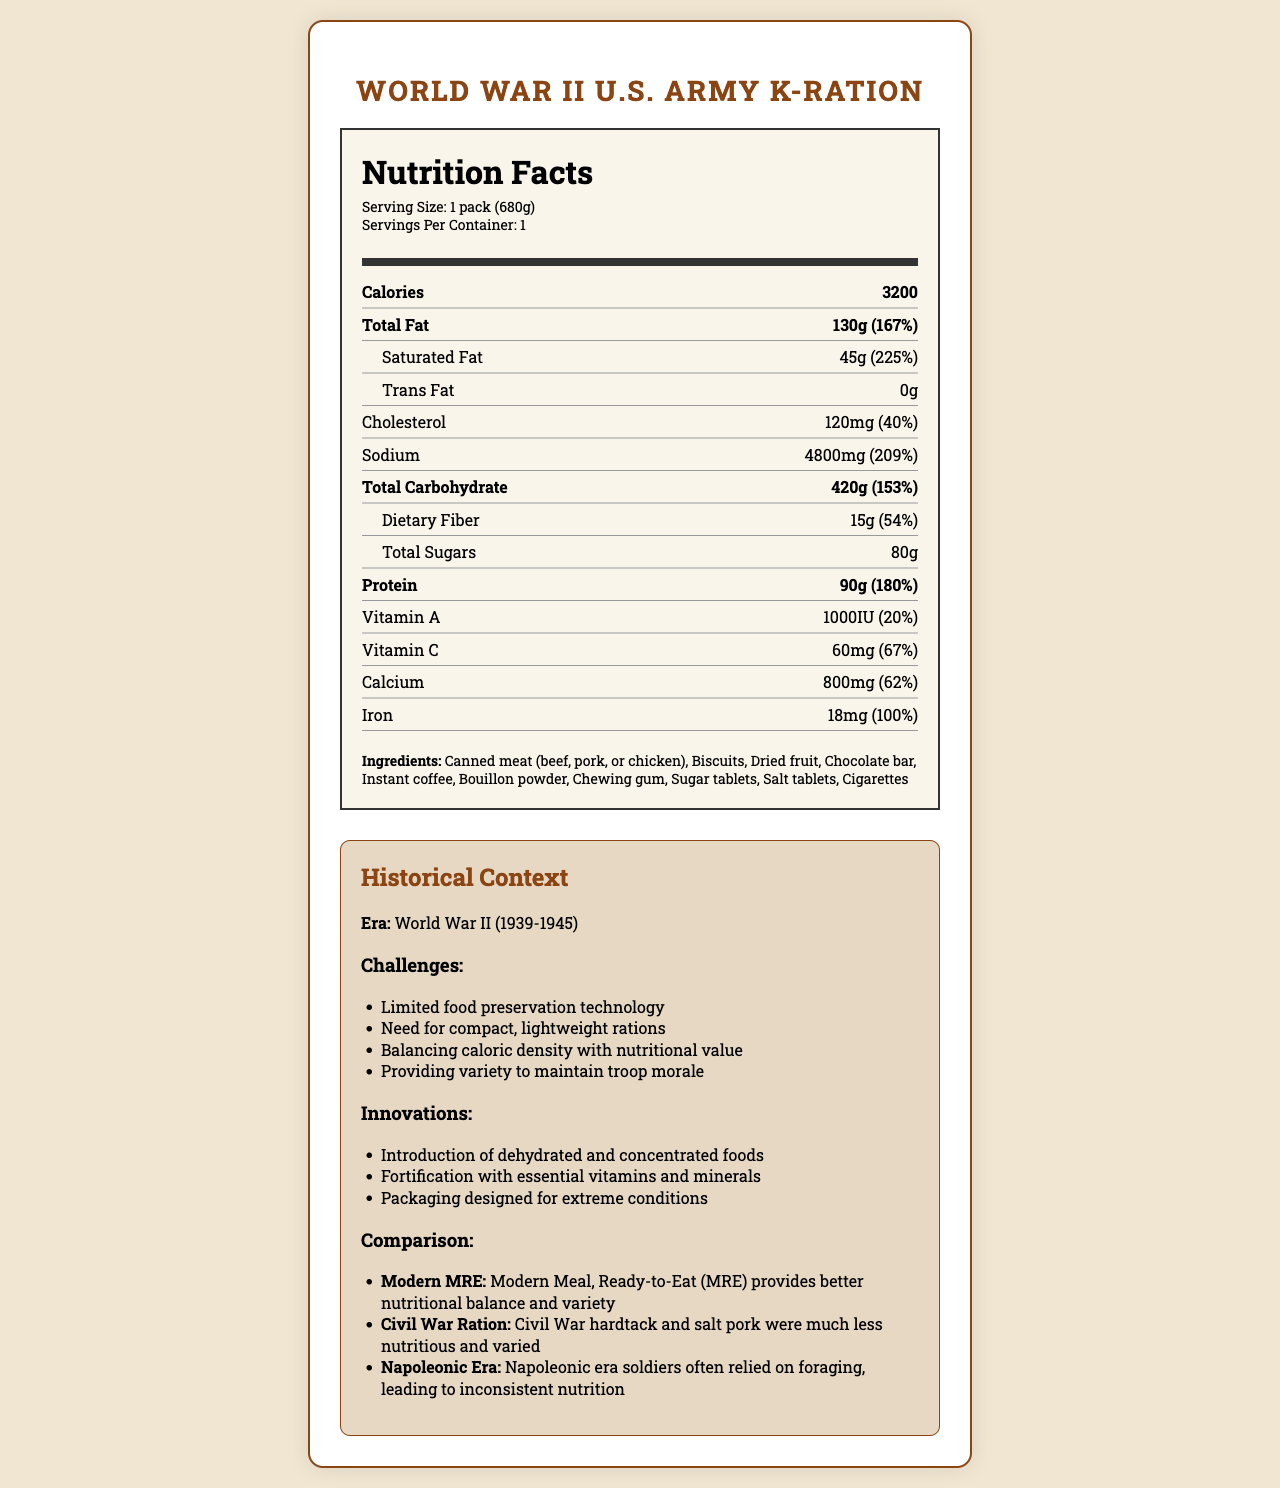what is the serving size for the World War II U.S. Army K-Ration? The serving size is explicitly mentioned at the beginning of the Nutrition Facts section as "Serving Size: 1 pack (680g)".
Answer: 1 pack (680g) how many calories does one K-Ration pack provide? The document states "Calories: 3200" under the Nutrition Facts section.
Answer: 3200 how much protein is there per serving of the K-Ration? The amount of protein per serving is listed as "Protein: 90g (180%)".
Answer: 90g what percentage of the daily value of sodium does a K-Ration contain? The daily value percentage for sodium is given as "Sodium: 4800mg (209%)".
Answer: 209% what were some challenges faced during the World War II era regarding rations? The section under Historical Context lists these challenges explicitly.
Answer: Limited food preservation technology, Need for compact, lightweight rations, Balancing caloric density with nutritional value, Providing variety to maintain troop morale how much total fat is in a K-Ration pack? A. 90g B. 130g C. 150g D. 45g The nutrition facts state "Total Fat: 130g (167%)".
Answer: B. 130g which of the following was not an ingredient in the K-Ration? I. Instant coffee II. Chocolate bar III. Fresh vegetables IV. Chewing gum Fresh vegetables are not listed among the ingredients which include "Canned meat, Biscuits, Dried fruit, Chocolate bar, Instant coffee, Bouillon powder, Chewing gum, Sugar tablets, Salt tablets, Cigarettes".
Answer: III. Fresh vegetables Did K-Ration packs include Vitamin C? The Nutrition Facts include "Vitamin C: 60mg (67%)", indicating the inclusion of Vitamin C in the ration.
Answer: Yes summarize the overall nutritional value and historical context of the World War II U.S. Army K-Ration. The summary requires understanding the entirety of the document including the nutrition facts and historical context provided.
Answer: The World War II U.S. Army K-Ration offered a high-caloric meal of 3200 calories with a substantial amount of protein (90g), fat (130g), and carbohydrates (420g), fortified with essential vitamins and minerals. Challenges included limited food preservation technology, the need for compact and lightweight meals, and maintaining variety to boost troop morale. Innovations included dehydrated and concentrated foods, fortified rations, and durable packaging. Compared to Modern MREs, it provided fewer nutritional balances and variety, but significantly more than Civil War-era rations and inconsistent Napoleonic era foraging. what are the sugar content and its impact on the daily value? The document mentions "Total Sugars: 80g" but does not provide a daily value percentage for sugars.
Answer: 80g; No daily value percentage given how does the nutritional value of the World War II U.S. Army K-Ration compare to a Modern MRE? The historical context section specifically compares the K-Ration unfavorably to Modern MREs in terms of nutritional balance and variety.
Answer: The Modern MRE provides better nutritional balance and variety how many cigarettes were included in each K-Ration pack? The document lists cigarettes as an ingredient but does not specify the quantity included in each pack.
Answer: Not enough information 